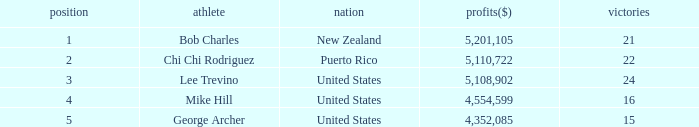What is the lowest level of Earnings($) to have a Wins value of 22 and a Rank lower than 2? None. 